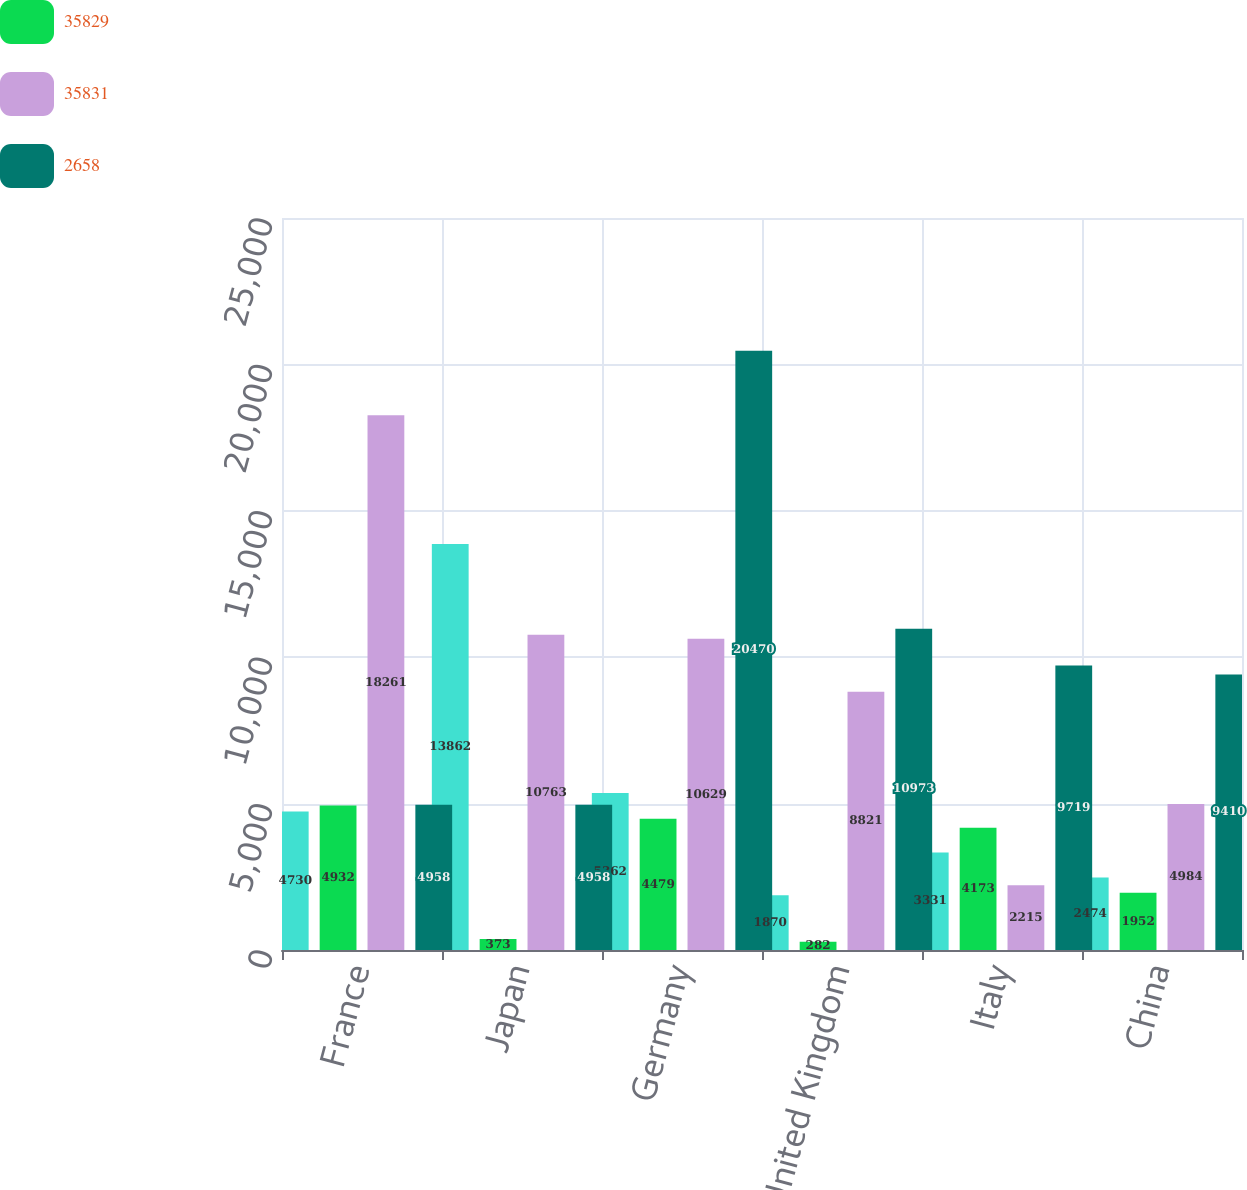Convert chart to OTSL. <chart><loc_0><loc_0><loc_500><loc_500><stacked_bar_chart><ecel><fcel>France<fcel>Japan<fcel>Germany<fcel>United Kingdom<fcel>Italy<fcel>China<nl><fcel>nan<fcel>4730<fcel>13862<fcel>5362<fcel>1870<fcel>3331<fcel>2474<nl><fcel>35829<fcel>4932<fcel>373<fcel>4479<fcel>282<fcel>4173<fcel>1952<nl><fcel>35831<fcel>18261<fcel>10763<fcel>10629<fcel>8821<fcel>2215<fcel>4984<nl><fcel>2658<fcel>4958<fcel>4958<fcel>20470<fcel>10973<fcel>9719<fcel>9410<nl></chart> 